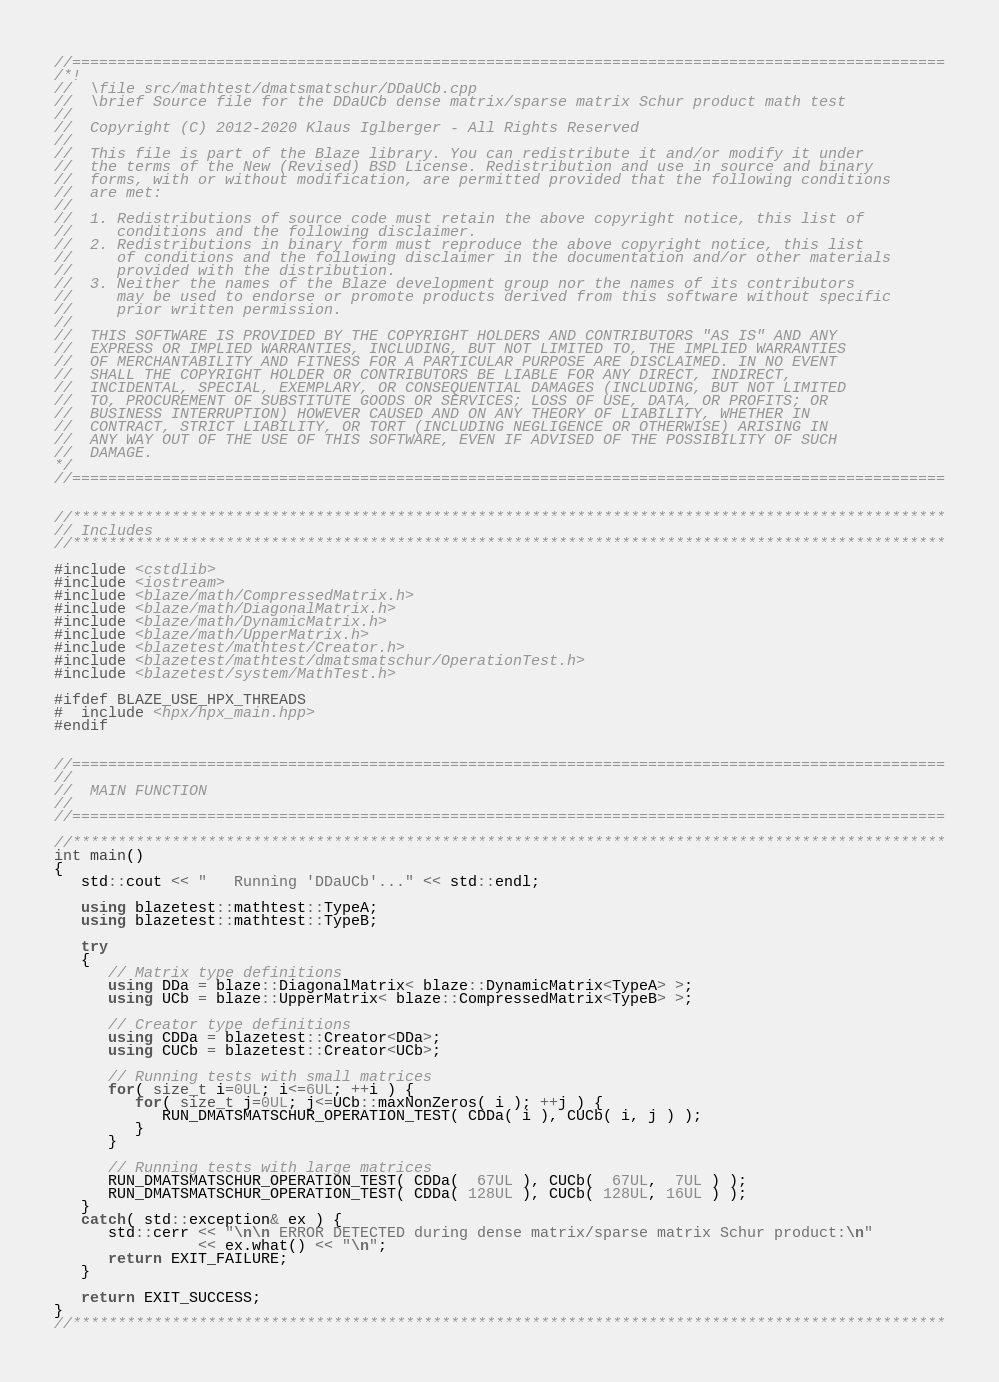Convert code to text. <code><loc_0><loc_0><loc_500><loc_500><_C++_>//=================================================================================================
/*!
//  \file src/mathtest/dmatsmatschur/DDaUCb.cpp
//  \brief Source file for the DDaUCb dense matrix/sparse matrix Schur product math test
//
//  Copyright (C) 2012-2020 Klaus Iglberger - All Rights Reserved
//
//  This file is part of the Blaze library. You can redistribute it and/or modify it under
//  the terms of the New (Revised) BSD License. Redistribution and use in source and binary
//  forms, with or without modification, are permitted provided that the following conditions
//  are met:
//
//  1. Redistributions of source code must retain the above copyright notice, this list of
//     conditions and the following disclaimer.
//  2. Redistributions in binary form must reproduce the above copyright notice, this list
//     of conditions and the following disclaimer in the documentation and/or other materials
//     provided with the distribution.
//  3. Neither the names of the Blaze development group nor the names of its contributors
//     may be used to endorse or promote products derived from this software without specific
//     prior written permission.
//
//  THIS SOFTWARE IS PROVIDED BY THE COPYRIGHT HOLDERS AND CONTRIBUTORS "AS IS" AND ANY
//  EXPRESS OR IMPLIED WARRANTIES, INCLUDING, BUT NOT LIMITED TO, THE IMPLIED WARRANTIES
//  OF MERCHANTABILITY AND FITNESS FOR A PARTICULAR PURPOSE ARE DISCLAIMED. IN NO EVENT
//  SHALL THE COPYRIGHT HOLDER OR CONTRIBUTORS BE LIABLE FOR ANY DIRECT, INDIRECT,
//  INCIDENTAL, SPECIAL, EXEMPLARY, OR CONSEQUENTIAL DAMAGES (INCLUDING, BUT NOT LIMITED
//  TO, PROCUREMENT OF SUBSTITUTE GOODS OR SERVICES; LOSS OF USE, DATA, OR PROFITS; OR
//  BUSINESS INTERRUPTION) HOWEVER CAUSED AND ON ANY THEORY OF LIABILITY, WHETHER IN
//  CONTRACT, STRICT LIABILITY, OR TORT (INCLUDING NEGLIGENCE OR OTHERWISE) ARISING IN
//  ANY WAY OUT OF THE USE OF THIS SOFTWARE, EVEN IF ADVISED OF THE POSSIBILITY OF SUCH
//  DAMAGE.
*/
//=================================================================================================


//*************************************************************************************************
// Includes
//*************************************************************************************************

#include <cstdlib>
#include <iostream>
#include <blaze/math/CompressedMatrix.h>
#include <blaze/math/DiagonalMatrix.h>
#include <blaze/math/DynamicMatrix.h>
#include <blaze/math/UpperMatrix.h>
#include <blazetest/mathtest/Creator.h>
#include <blazetest/mathtest/dmatsmatschur/OperationTest.h>
#include <blazetest/system/MathTest.h>

#ifdef BLAZE_USE_HPX_THREADS
#  include <hpx/hpx_main.hpp>
#endif


//=================================================================================================
//
//  MAIN FUNCTION
//
//=================================================================================================

//*************************************************************************************************
int main()
{
   std::cout << "   Running 'DDaUCb'..." << std::endl;

   using blazetest::mathtest::TypeA;
   using blazetest::mathtest::TypeB;

   try
   {
      // Matrix type definitions
      using DDa = blaze::DiagonalMatrix< blaze::DynamicMatrix<TypeA> >;
      using UCb = blaze::UpperMatrix< blaze::CompressedMatrix<TypeB> >;

      // Creator type definitions
      using CDDa = blazetest::Creator<DDa>;
      using CUCb = blazetest::Creator<UCb>;

      // Running tests with small matrices
      for( size_t i=0UL; i<=6UL; ++i ) {
         for( size_t j=0UL; j<=UCb::maxNonZeros( i ); ++j ) {
            RUN_DMATSMATSCHUR_OPERATION_TEST( CDDa( i ), CUCb( i, j ) );
         }
      }

      // Running tests with large matrices
      RUN_DMATSMATSCHUR_OPERATION_TEST( CDDa(  67UL ), CUCb(  67UL,  7UL ) );
      RUN_DMATSMATSCHUR_OPERATION_TEST( CDDa( 128UL ), CUCb( 128UL, 16UL ) );
   }
   catch( std::exception& ex ) {
      std::cerr << "\n\n ERROR DETECTED during dense matrix/sparse matrix Schur product:\n"
                << ex.what() << "\n";
      return EXIT_FAILURE;
   }

   return EXIT_SUCCESS;
}
//*************************************************************************************************
</code> 